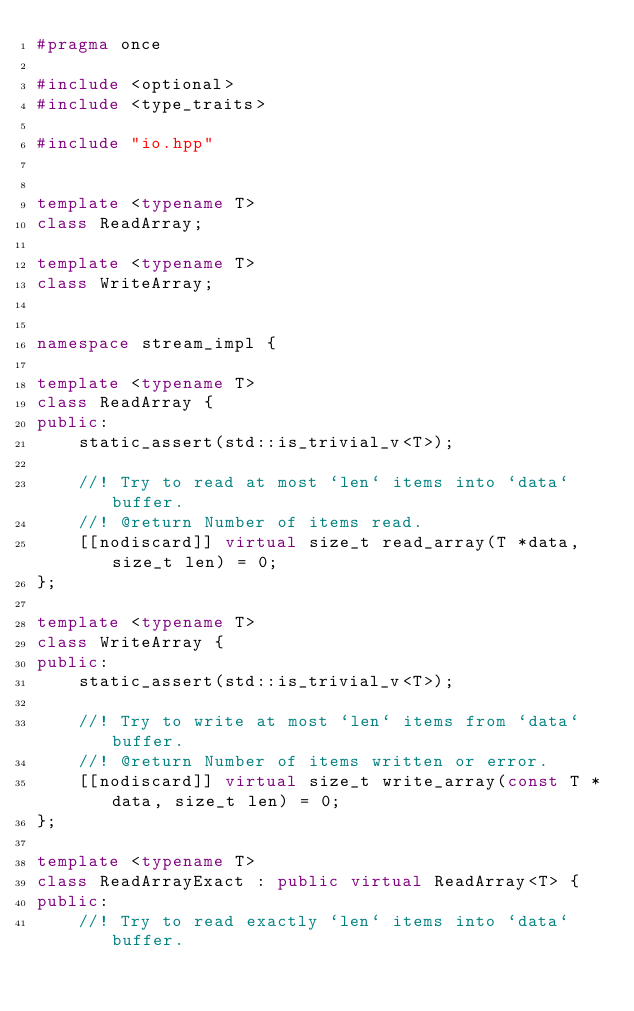<code> <loc_0><loc_0><loc_500><loc_500><_C++_>#pragma once

#include <optional>
#include <type_traits>

#include "io.hpp"


template <typename T>
class ReadArray;

template <typename T>
class WriteArray;


namespace stream_impl {

template <typename T>
class ReadArray {
public:
    static_assert(std::is_trivial_v<T>);

    //! Try to read at most `len` items into `data` buffer.
    //! @return Number of items read.
    [[nodiscard]] virtual size_t read_array(T *data, size_t len) = 0;
};

template <typename T>
class WriteArray {
public:
    static_assert(std::is_trivial_v<T>);

    //! Try to write at most `len` items from `data` buffer.
    //! @return Number of items written or error.
    [[nodiscard]] virtual size_t write_array(const T *data, size_t len) = 0;
};

template <typename T>
class ReadArrayExact : public virtual ReadArray<T> {
public:
    //! Try to read exactly `len` items into `data` buffer.</code> 